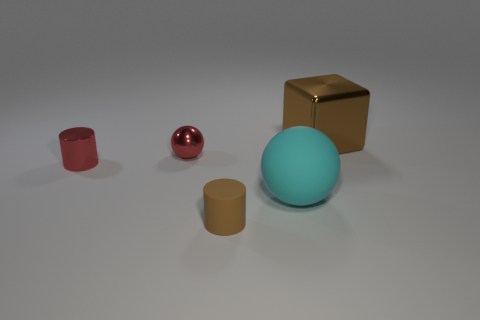Are there any other things that have the same material as the large cyan object?
Give a very brief answer. Yes. There is a brown object that is to the left of the brown object behind the large thing on the left side of the brown metal object; what is its material?
Provide a short and direct response. Rubber. Is the shape of the small brown matte object the same as the large shiny thing?
Offer a terse response. No. There is a tiny object that is the same shape as the large cyan rubber object; what is it made of?
Ensure brevity in your answer.  Metal. How many small shiny objects are the same color as the large rubber object?
Your answer should be very brief. 0. What size is the red sphere that is made of the same material as the cube?
Provide a short and direct response. Small. How many yellow things are either balls or tiny shiny cylinders?
Give a very brief answer. 0. What number of big cyan balls are on the left side of the tiny shiny thing in front of the small shiny sphere?
Provide a short and direct response. 0. Are there more tiny brown objects to the left of the matte cylinder than small metal things that are in front of the big cyan matte thing?
Your answer should be very brief. No. What is the large brown thing made of?
Keep it short and to the point. Metal. 